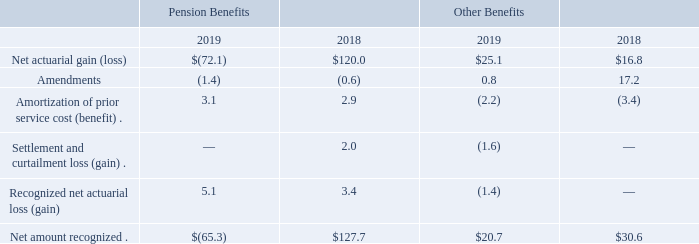In fiscal 2019, 2018, and 2017, the Company recorded charges of $5.1 million, $3.4 million, and $1.2 million, respectively, reflecting the year-end write-off of actuarial losses in excess of 10% of our pension liability.
The Company recorded an expense of $0.3 million (primarily within restructuring activities), $0.6 million (primarily within restructuring activities), and $4.0 million ($2.1 million was recorded in discontinued operations and $1.9 million was recorded in restructuring activities) during fiscal 2019, 2018, and 2017, respectively, related to our expected incurrence of certain multi-employer plan withdrawal costs.
Other changes in plan assets and benefit obligations recognized in other comprehensive income (loss) were:
Notes to Consolidated Financial Statements - (Continued) Fiscal Years Ended May 26, 2019, May 27, 2018, and May 28, 2017 (columnar dollars in millions except per share amounts)
How much were the charges of the year-end write-off of actuarial losses during fiscal 2017, 2018, and 2019, respectively? $1.2 million, $3.4 million, $5.1 million. What is the breakdown of $4.0 million expense during fiscal 2017 that was related to expected incurrence of certain multi-employer plan withdrawal costs? $2.1 million was recorded in discontinued operations and $1.9 million was recorded in restructuring activities. What is the net amount recognized  for pension benefit during the fiscal year 2018 and 2019, respectively?
Answer scale should be: million. $127.7, (65.3). What is the average amount of amendments for all benefits for fiscal 2018 and 2019?
Answer scale should be: million. (-1.4+(-0.6)+0.8+17.2)/4 
Answer: 4. What is the percentage change in the net amount recognized for other benefits from 2018 to 2019?
Answer scale should be: percent. (20.7-30.6)/30.6 
Answer: -32.35. What is the percentage change in amortization of prior service cost for pension benefits in 2019 compared to 2018?
Answer scale should be: percent. (3.1-2.9)/2.9 
Answer: 6.9. 